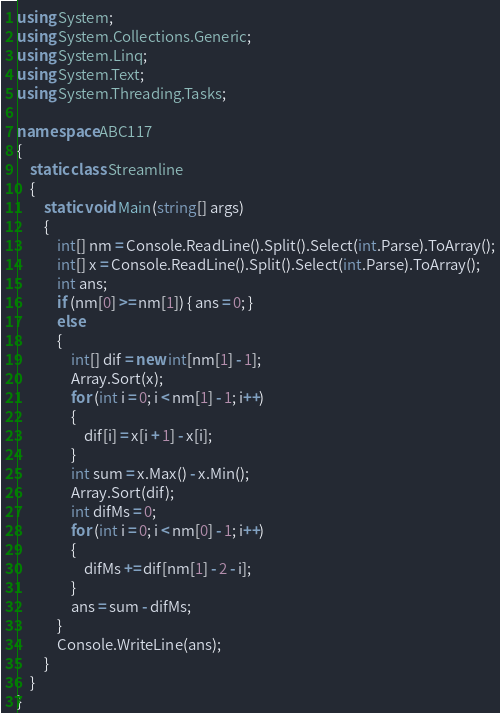<code> <loc_0><loc_0><loc_500><loc_500><_C#_>using System;
using System.Collections.Generic;
using System.Linq;
using System.Text;
using System.Threading.Tasks;

namespace ABC117
{
    static class Streamline
    {
        static void Main(string[] args)
        {
            int[] nm = Console.ReadLine().Split().Select(int.Parse).ToArray();
            int[] x = Console.ReadLine().Split().Select(int.Parse).ToArray();
            int ans;
            if (nm[0] >= nm[1]) { ans = 0; }
            else
            {
                int[] dif = new int[nm[1] - 1];
                Array.Sort(x);
                for (int i = 0; i < nm[1] - 1; i++)
                {
                    dif[i] = x[i + 1] - x[i];
                }
                int sum = x.Max() - x.Min();
                Array.Sort(dif);
                int difMs = 0;
                for (int i = 0; i < nm[0] - 1; i++)
                {
                    difMs += dif[nm[1] - 2 - i];
                }
                ans = sum - difMs;
            }
            Console.WriteLine(ans);
        }
    }
}
</code> 